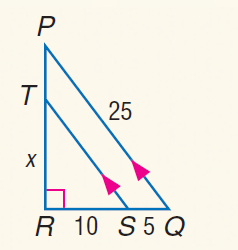Answer the mathemtical geometry problem and directly provide the correct option letter.
Question: Find S T.
Choices: A: 32 / 2 B: \frac { 50 } { 3 } C: 17 D: 18 B 